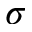<formula> <loc_0><loc_0><loc_500><loc_500>\sigma</formula> 